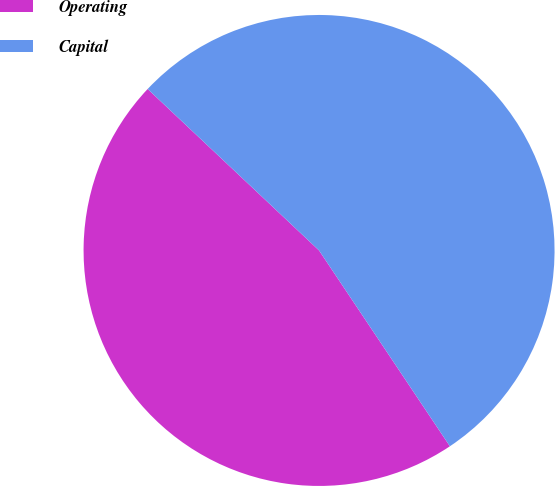Convert chart. <chart><loc_0><loc_0><loc_500><loc_500><pie_chart><fcel>Operating<fcel>Capital<nl><fcel>46.4%<fcel>53.6%<nl></chart> 